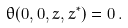<formula> <loc_0><loc_0><loc_500><loc_500>\theta ( 0 , 0 , z , z ^ { * } ) = 0 \, .</formula> 